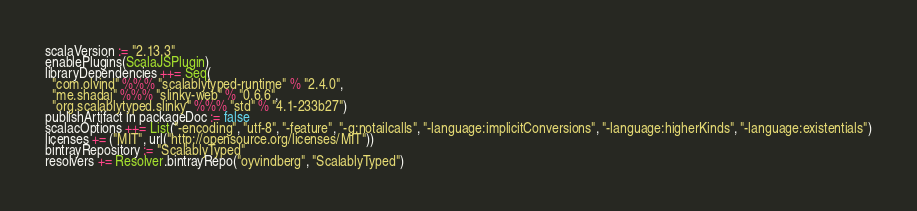<code> <loc_0><loc_0><loc_500><loc_500><_Scala_>scalaVersion := "2.13.3"
enablePlugins(ScalaJSPlugin)
libraryDependencies ++= Seq(
  "com.olvind" %%% "scalablytyped-runtime" % "2.4.0",
  "me.shadaj" %%% "slinky-web" % "0.6.6",
  "org.scalablytyped.slinky" %%% "std" % "4.1-233b27")
publishArtifact in packageDoc := false
scalacOptions ++= List("-encoding", "utf-8", "-feature", "-g:notailcalls", "-language:implicitConversions", "-language:higherKinds", "-language:existentials")
licenses += ("MIT", url("http://opensource.org/licenses/MIT"))
bintrayRepository := "ScalablyTyped"
resolvers += Resolver.bintrayRepo("oyvindberg", "ScalablyTyped")
</code> 